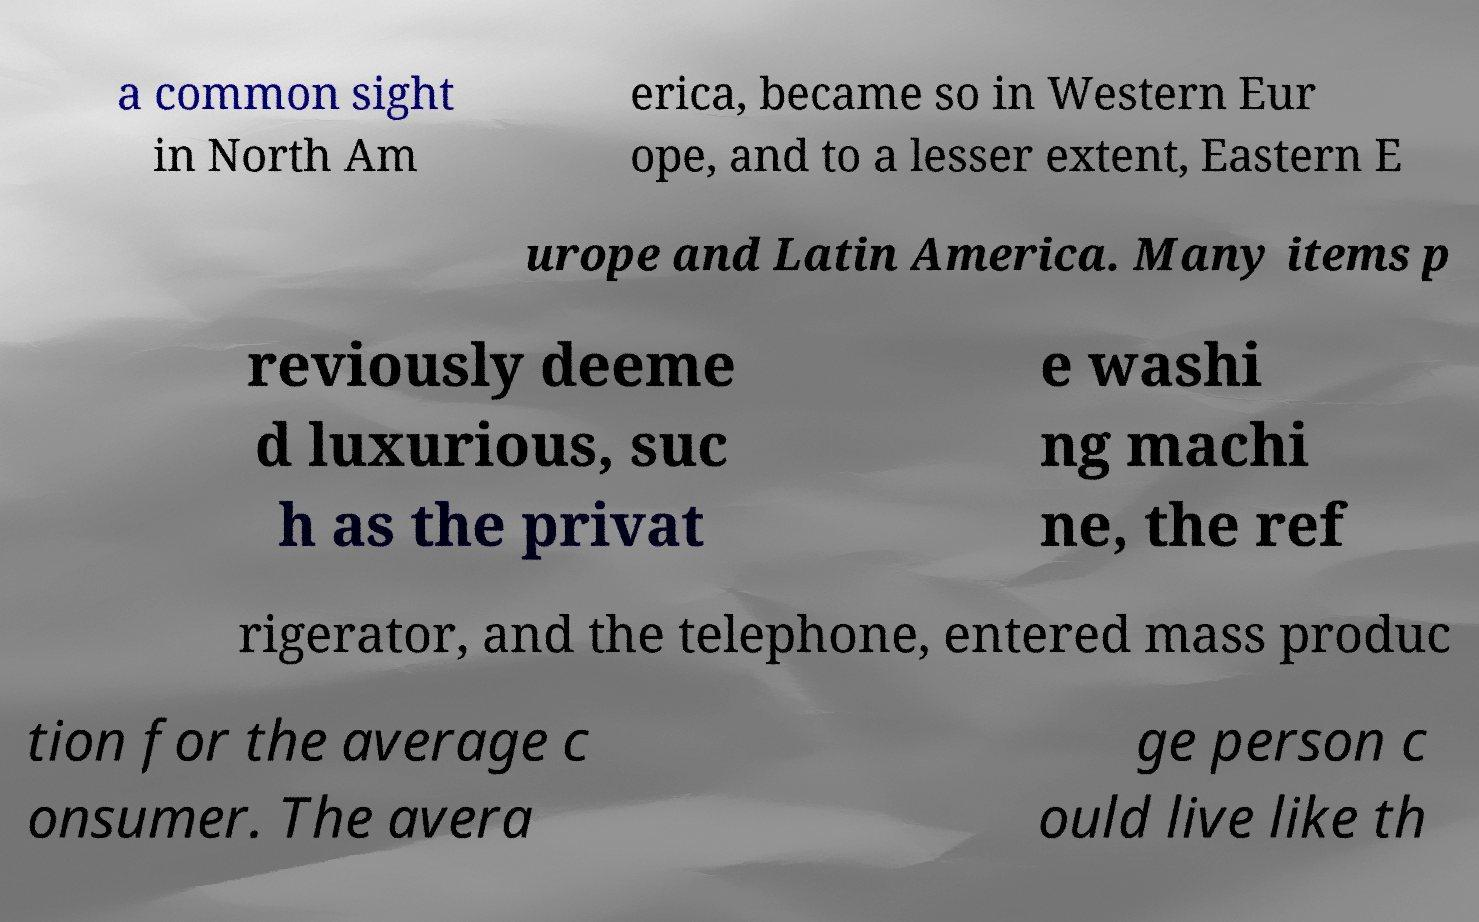Can you accurately transcribe the text from the provided image for me? a common sight in North Am erica, became so in Western Eur ope, and to a lesser extent, Eastern E urope and Latin America. Many items p reviously deeme d luxurious, suc h as the privat e washi ng machi ne, the ref rigerator, and the telephone, entered mass produc tion for the average c onsumer. The avera ge person c ould live like th 